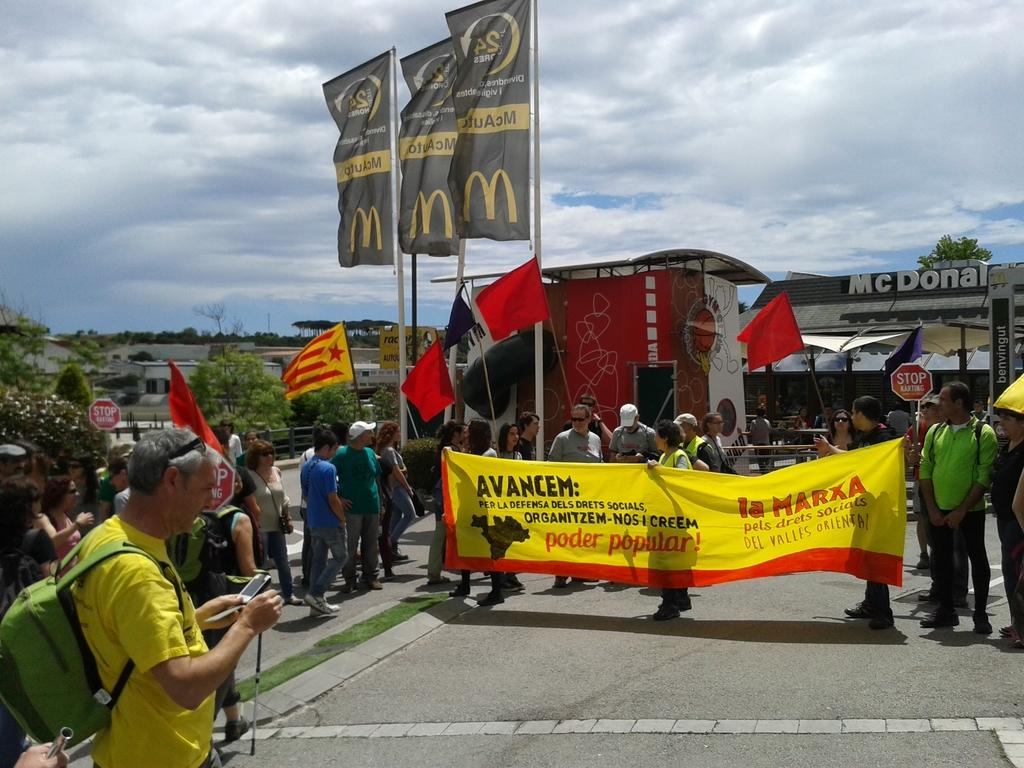<image>
Offer a succinct explanation of the picture presented. A group of people holding a banner that is yellow,red and black and says AVANCEM. 